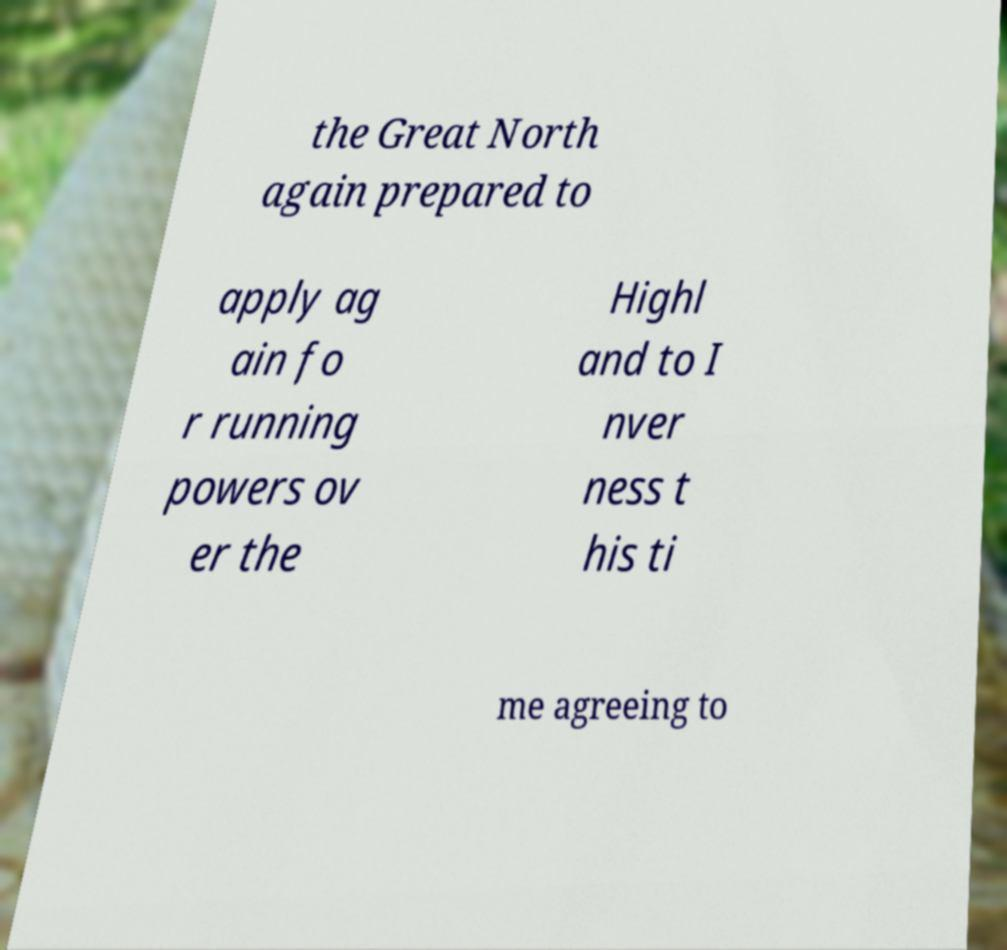Please read and relay the text visible in this image. What does it say? the Great North again prepared to apply ag ain fo r running powers ov er the Highl and to I nver ness t his ti me agreeing to 